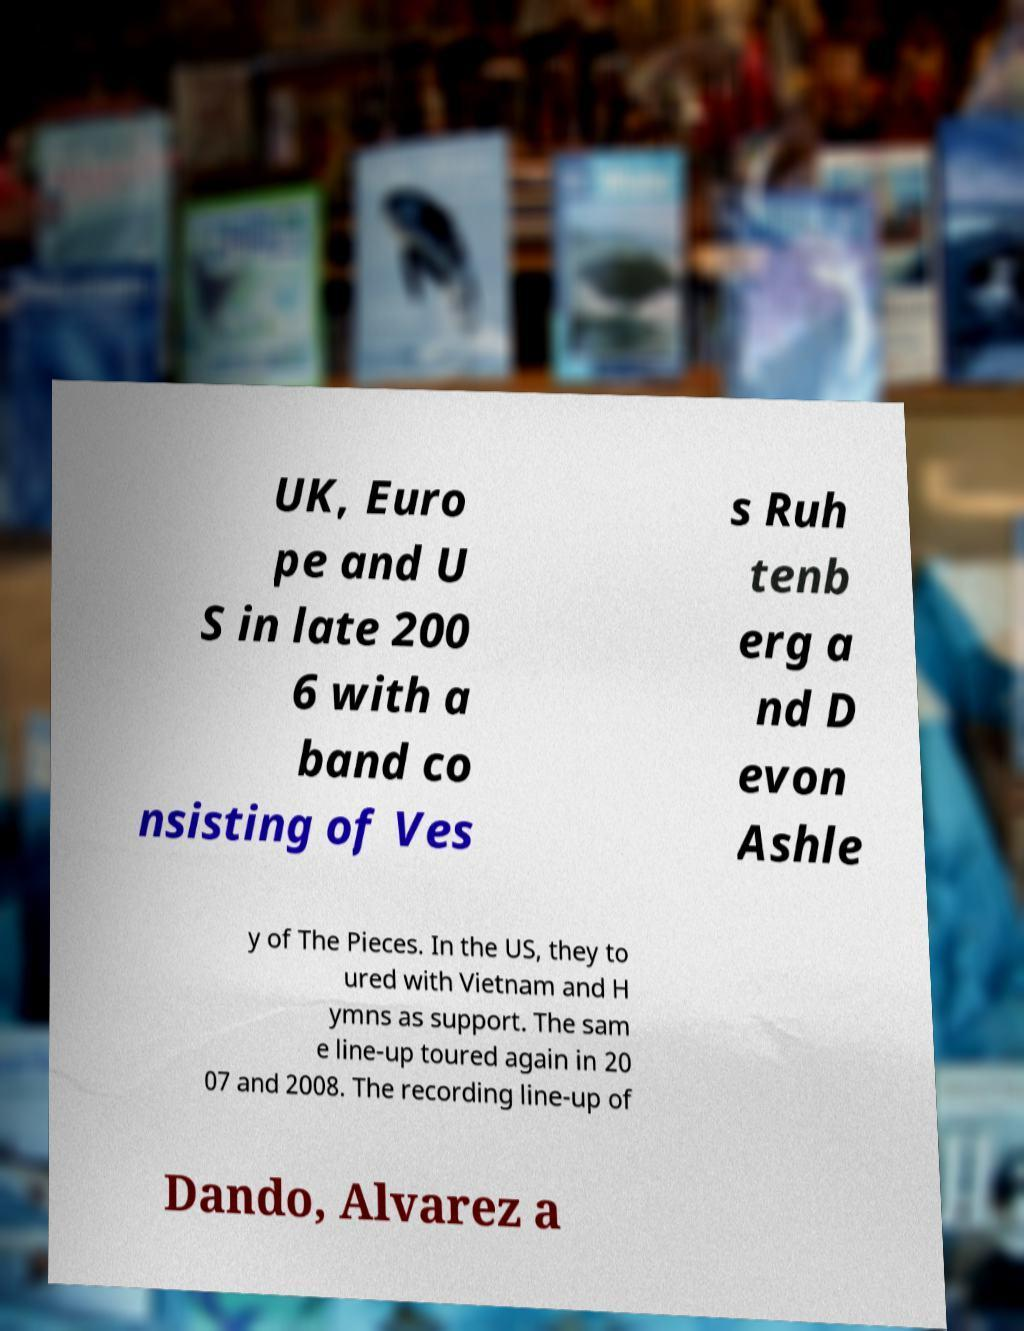Can you read and provide the text displayed in the image?This photo seems to have some interesting text. Can you extract and type it out for me? UK, Euro pe and U S in late 200 6 with a band co nsisting of Ves s Ruh tenb erg a nd D evon Ashle y of The Pieces. In the US, they to ured with Vietnam and H ymns as support. The sam e line-up toured again in 20 07 and 2008. The recording line-up of Dando, Alvarez a 